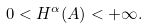<formula> <loc_0><loc_0><loc_500><loc_500>0 < H ^ { \alpha } ( A ) < + \infty .</formula> 